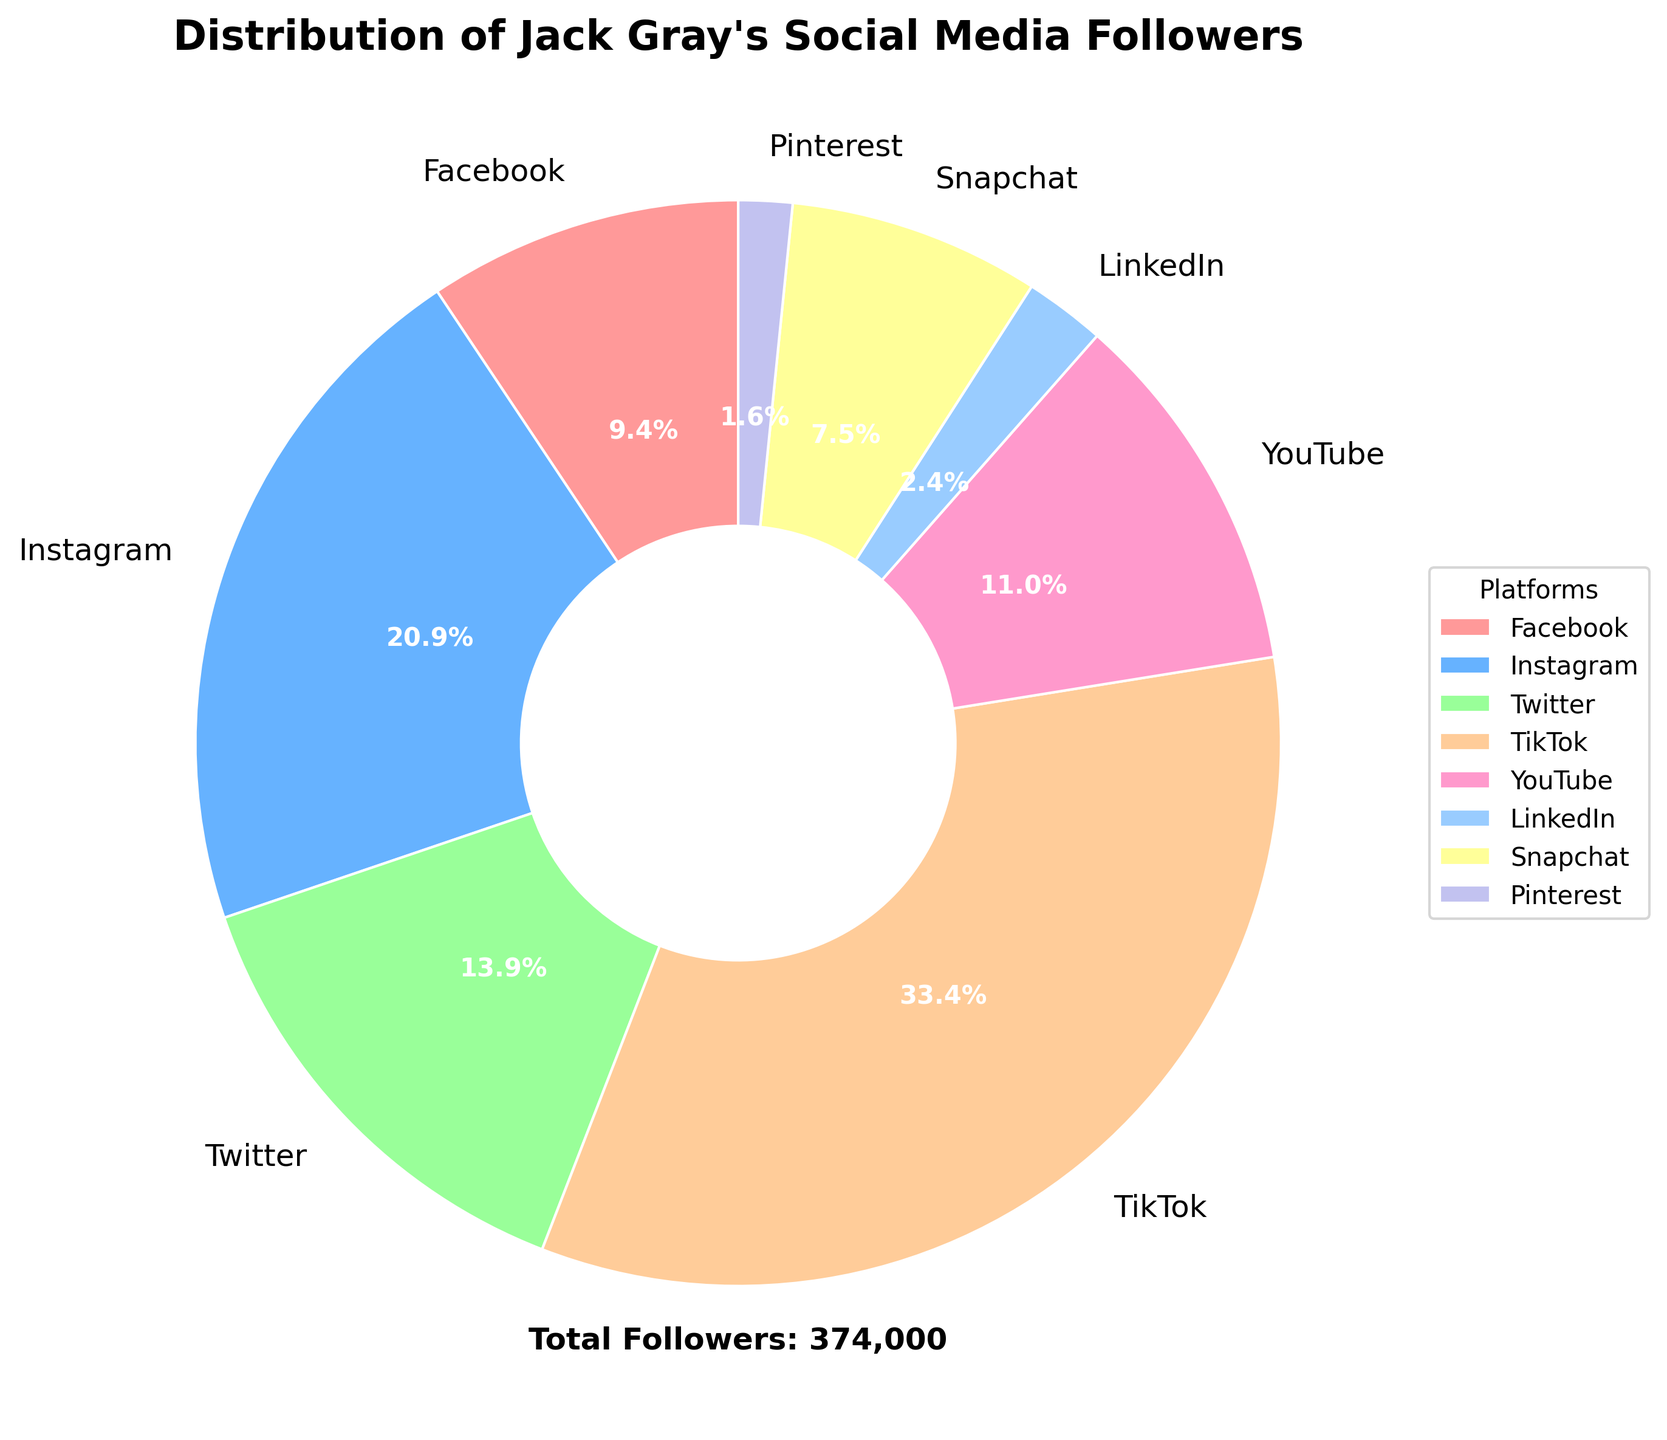What percentage of Jack Gray's followers are on TikTok? TikTok has 125,000 followers out of the total followers. The percentage can be calculated as (125000 / (35000 + 78000 + 52000 + 125000 + 41000 + 9000 + 28000 + 6000)) * 100 = 37.0%
Answer: 37.0% What is the total number of Jack Gray's followers on all platforms combined? Sum up the followers across all platforms: 35000 (Facebook) + 78000 (Instagram) + 52000 (Twitter) + 125000 (TikTok) + 41000 (YouTube) + 9000 (LinkedIn) + 28000 (Snapchat) + 6000 (Pinterest) = 373000.
Answer: 373000 Which platform has the smallest share of Jack Gray's followers, and what is that share? Pinterest has the smallest number of followers at 6000, which is calculated as (6000 / 373000) * 100 = 1.6% of the total followers.
Answer: Pinterest, 1.6% How does the number of followers on Instagram compare to Twitter? Instagram has 78000 followers, and Twitter has 52000 followers. To compare, Instagram has more followers, specifically 78000 - 52000 = 26000 more followers than Twitter.
Answer: Instagram has 26000 more followers If you sum up the followers from Facebook, Instagram, and Twitter, do they exceed the number of followers on TikTok? The sum of followers for Facebook, Instagram, and Twitter is 35000 + 78000 + 52000 = 165000. TikTok has 125000 followers. Since 165000 is greater than 125000, they indeed exceed TikTok's followers.
Answer: Yes, they exceed by 40000 followers Estimate the visual size relationship between the wedge representing Facebook and the wedge representing Pinterest. Facebook's wedge is larger than Pinterest's. Given the follower numbers, Facebook has 35000 followers making 9.4% while Pinterest has 6000 followers making up 1.6%. The visual size of Facebook's wedge (9.4%) is approximately 5.9 times larger than Pinterest's wedge (1.6%).
Answer: Facebook's wedge is about 5.9 times larger than Pinterest's Which platforms have a larger share of followers compared to YouTube? YouTube has 41000 followers (11.0%). TikTok (125000, 37.0%), Instagram (78000, 20.9%), and Twitter (52000, 13.9%) all have a larger share of followers compared to YouTube.
Answer: TikTok, Instagram, Twitter Calculate the ratio of followers between Snapchat and LinkedIn. Snapchat has 28000 followers and LinkedIn has 9000 followers. The ratio is calculated as 28000 / 9000 = 3.11.
Answer: 3.11 What percentage of Jack Gray's followers are on professional networking sites like LinkedIn and Pinterest combined? LinkedIn has 9000 followers and Pinterest has 6000 followers. Combined, they have 15000 followers. The percentage is (15000 / 373000) * 100 = 4.0%.
Answer: 4.0% What is the difference in followers between the most popular platform (TikTok) and the least popular platform (Pinterest)? TikTok has 125000 followers and Pinterest has 6000 followers. The difference is 125000 - 6000 = 119000 followers.
Answer: 119000 